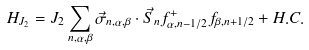Convert formula to latex. <formula><loc_0><loc_0><loc_500><loc_500>H _ { J _ { 2 } } = J _ { 2 } \sum _ { n , \alpha , \beta } { \vec { \sigma } } _ { n , \alpha , \beta } \cdot \vec { S } _ { n } f _ { \alpha , n - 1 / 2 } ^ { + } f _ { \beta , n + 1 / 2 } + H . C .</formula> 